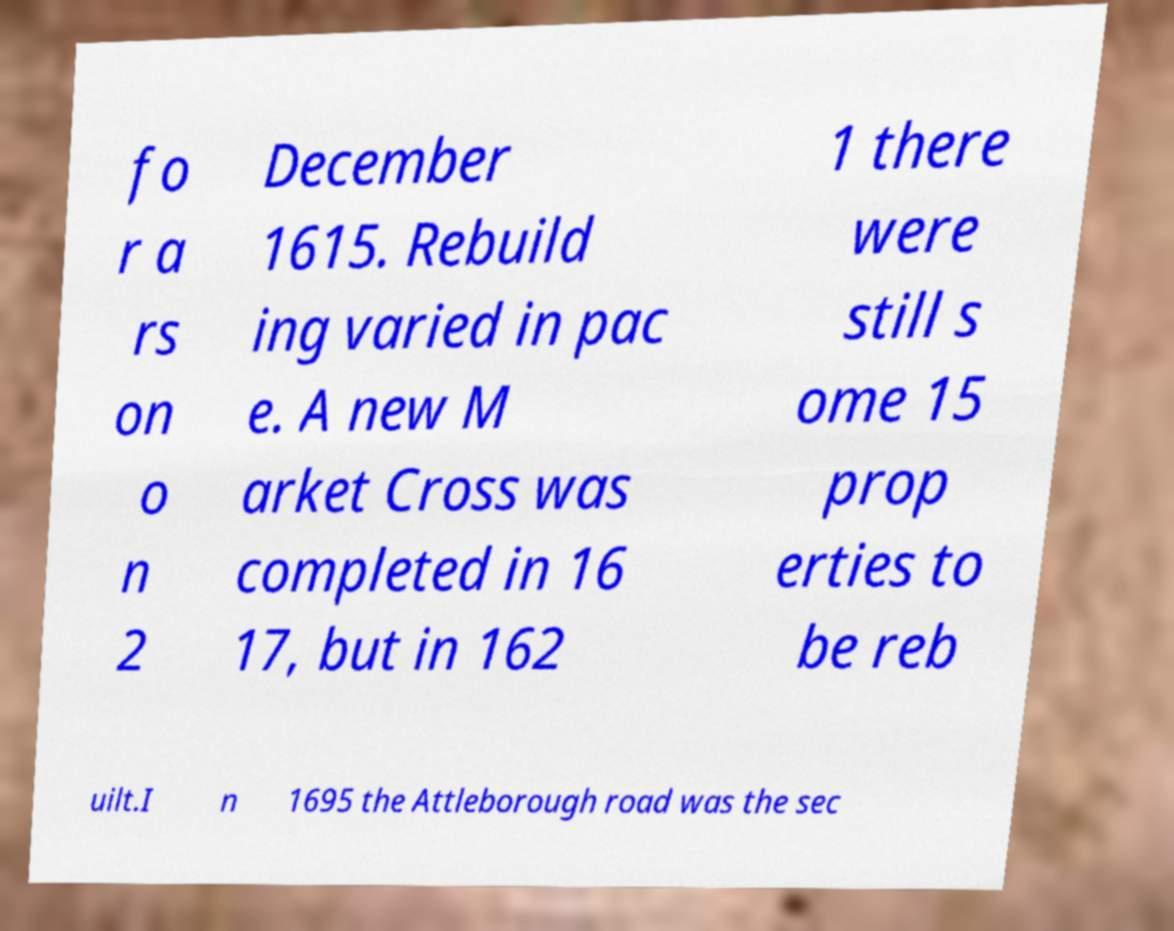Could you assist in decoding the text presented in this image and type it out clearly? fo r a rs on o n 2 December 1615. Rebuild ing varied in pac e. A new M arket Cross was completed in 16 17, but in 162 1 there were still s ome 15 prop erties to be reb uilt.I n 1695 the Attleborough road was the sec 